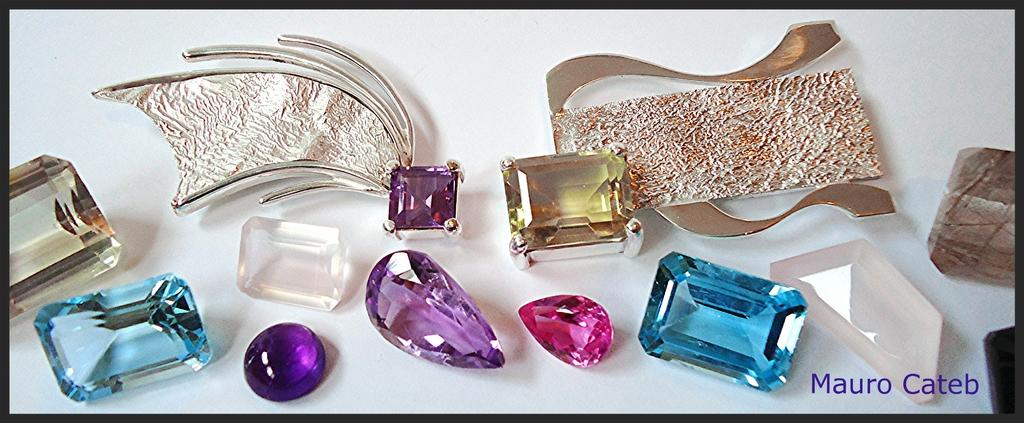What type of objects are present in the image? There are different color stones in the image. What is the background or surface on which the stones are placed? The stones are on a white surface. Is there any additional mark or symbol in the image? Yes, there is a watermark in the right bottom corner of the image. What type of paste is being used by the person wearing a mask in the image? There is no person wearing a mask or using any paste in the image; it only features different color stones on a white surface with a watermark. 